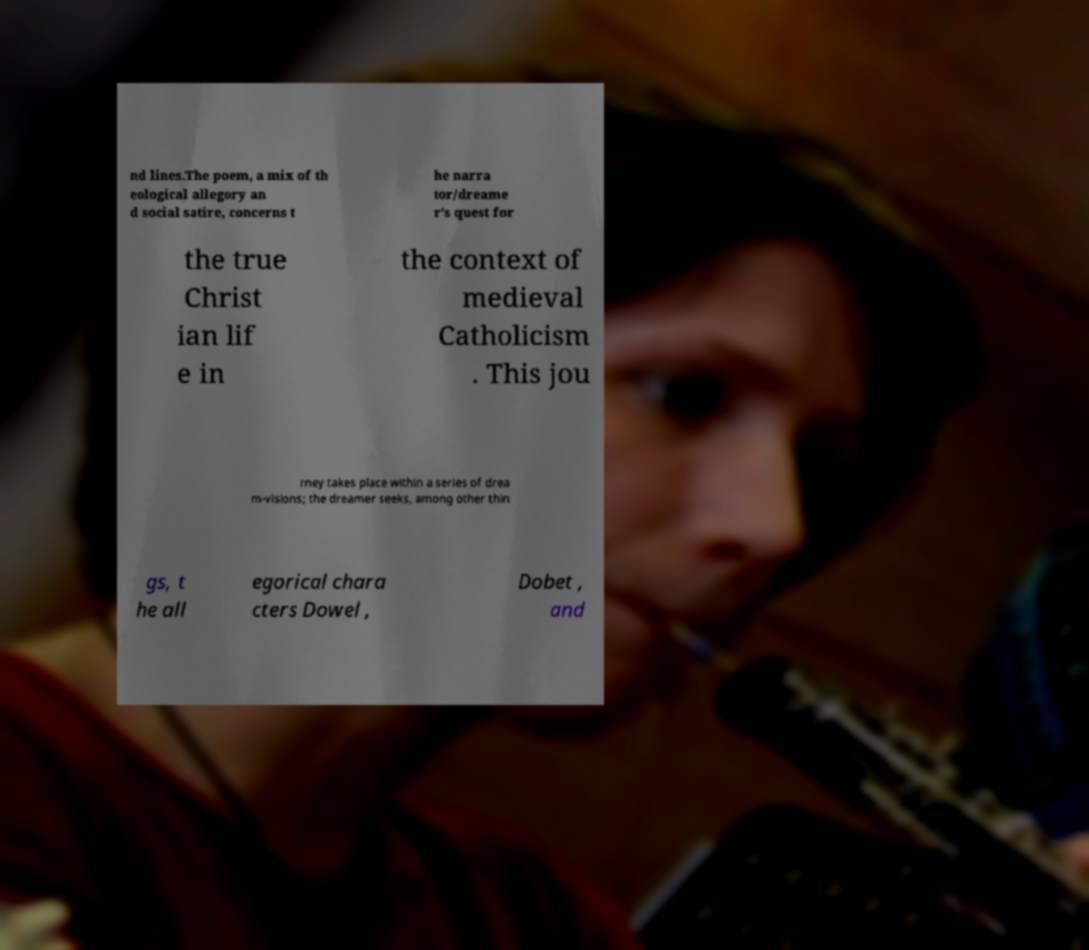For documentation purposes, I need the text within this image transcribed. Could you provide that? nd lines.The poem, a mix of th eological allegory an d social satire, concerns t he narra tor/dreame r's quest for the true Christ ian lif e in the context of medieval Catholicism . This jou rney takes place within a series of drea m-visions; the dreamer seeks, among other thin gs, t he all egorical chara cters Dowel , Dobet , and 